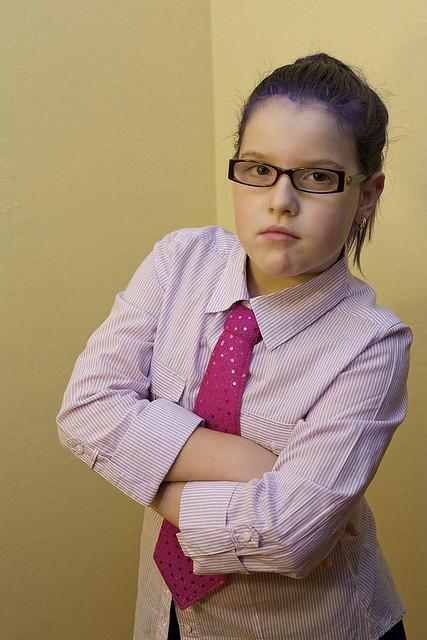What color is the girl's tie?
Give a very brief answer. Pink. Does the girl have long hair?
Write a very short answer. Yes. How is she holding her arms?
Quick response, please. Crossed. Is she wearing a bonnet?
Keep it brief. No. Does the shirt fit?
Answer briefly. Yes. Is the girl blonde?
Concise answer only. No. Is she wearing a bowtie?
Concise answer only. No. Is the girl wearing glasses?
Answer briefly. Yes. What color is the tie?
Quick response, please. Pink. Is this a man?
Quick response, please. No. Is the child reading?
Write a very short answer. No. Is this a boy or a girl?
Be succinct. Girl. Is the girl eating?
Be succinct. No. What gender is this person?
Quick response, please. Female. 